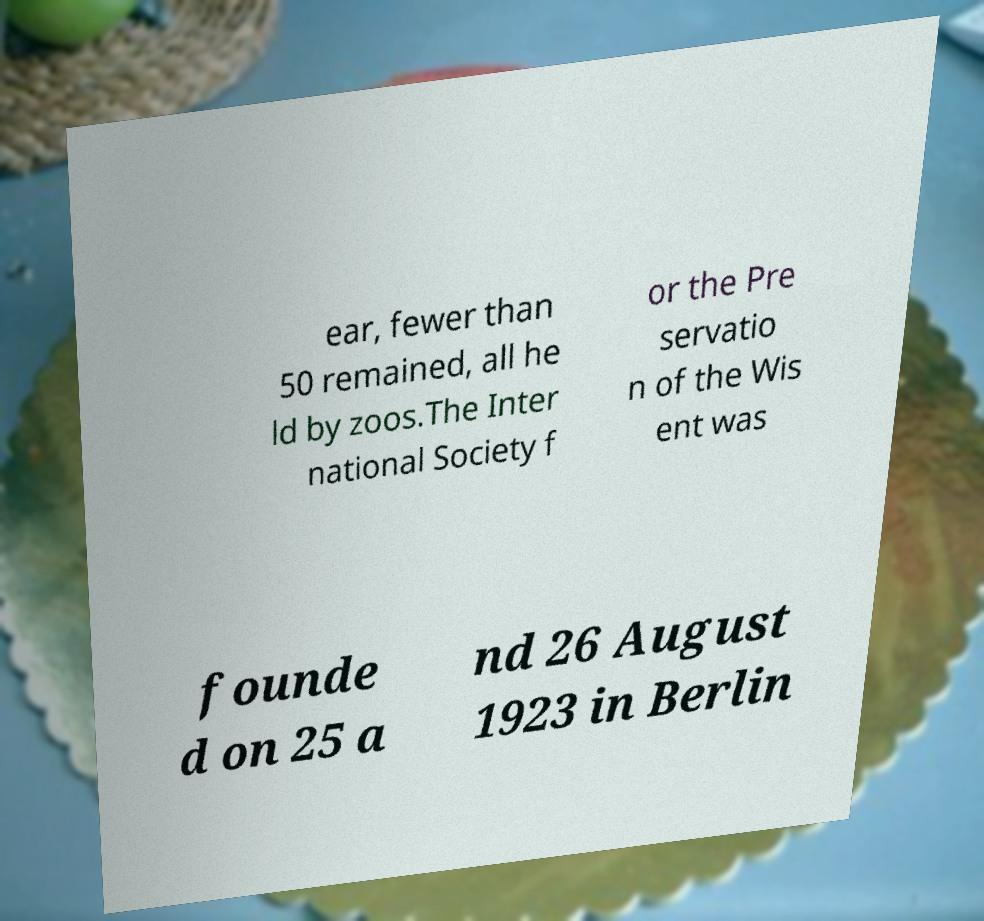What messages or text are displayed in this image? I need them in a readable, typed format. ear, fewer than 50 remained, all he ld by zoos.The Inter national Society f or the Pre servatio n of the Wis ent was founde d on 25 a nd 26 August 1923 in Berlin 